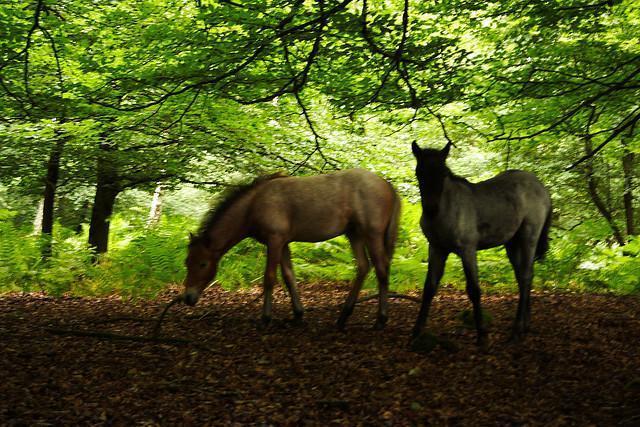How many horses can be seen?
Give a very brief answer. 2. 